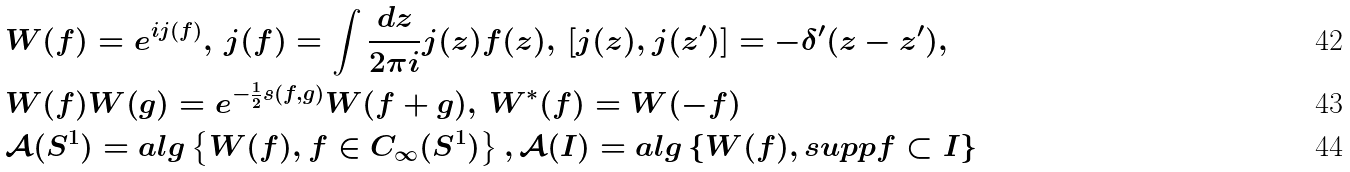<formula> <loc_0><loc_0><loc_500><loc_500>& W ( f ) = e ^ { i j ( f ) } , \, j ( f ) = \int \frac { d z } { 2 \pi i } j ( z ) f ( z ) , \, \left [ j ( z ) , j ( z ^ { \prime } ) \right ] = - \delta ^ { \prime } ( z - z ^ { \prime } ) , \, \\ & W ( f ) W ( g ) = e ^ { - \frac { 1 } { 2 } s ( f , g ) } W ( f + g ) , \, W ^ { \ast } ( f ) = W ( - f ) \\ & \mathcal { A } ( S ^ { 1 } ) = a l g \left \{ W ( f ) , f \in C _ { \infty } ( S ^ { 1 } ) \right \} , \mathcal { A } ( I ) = a l g \left \{ W ( f ) , s u p p f \subset I \right \}</formula> 